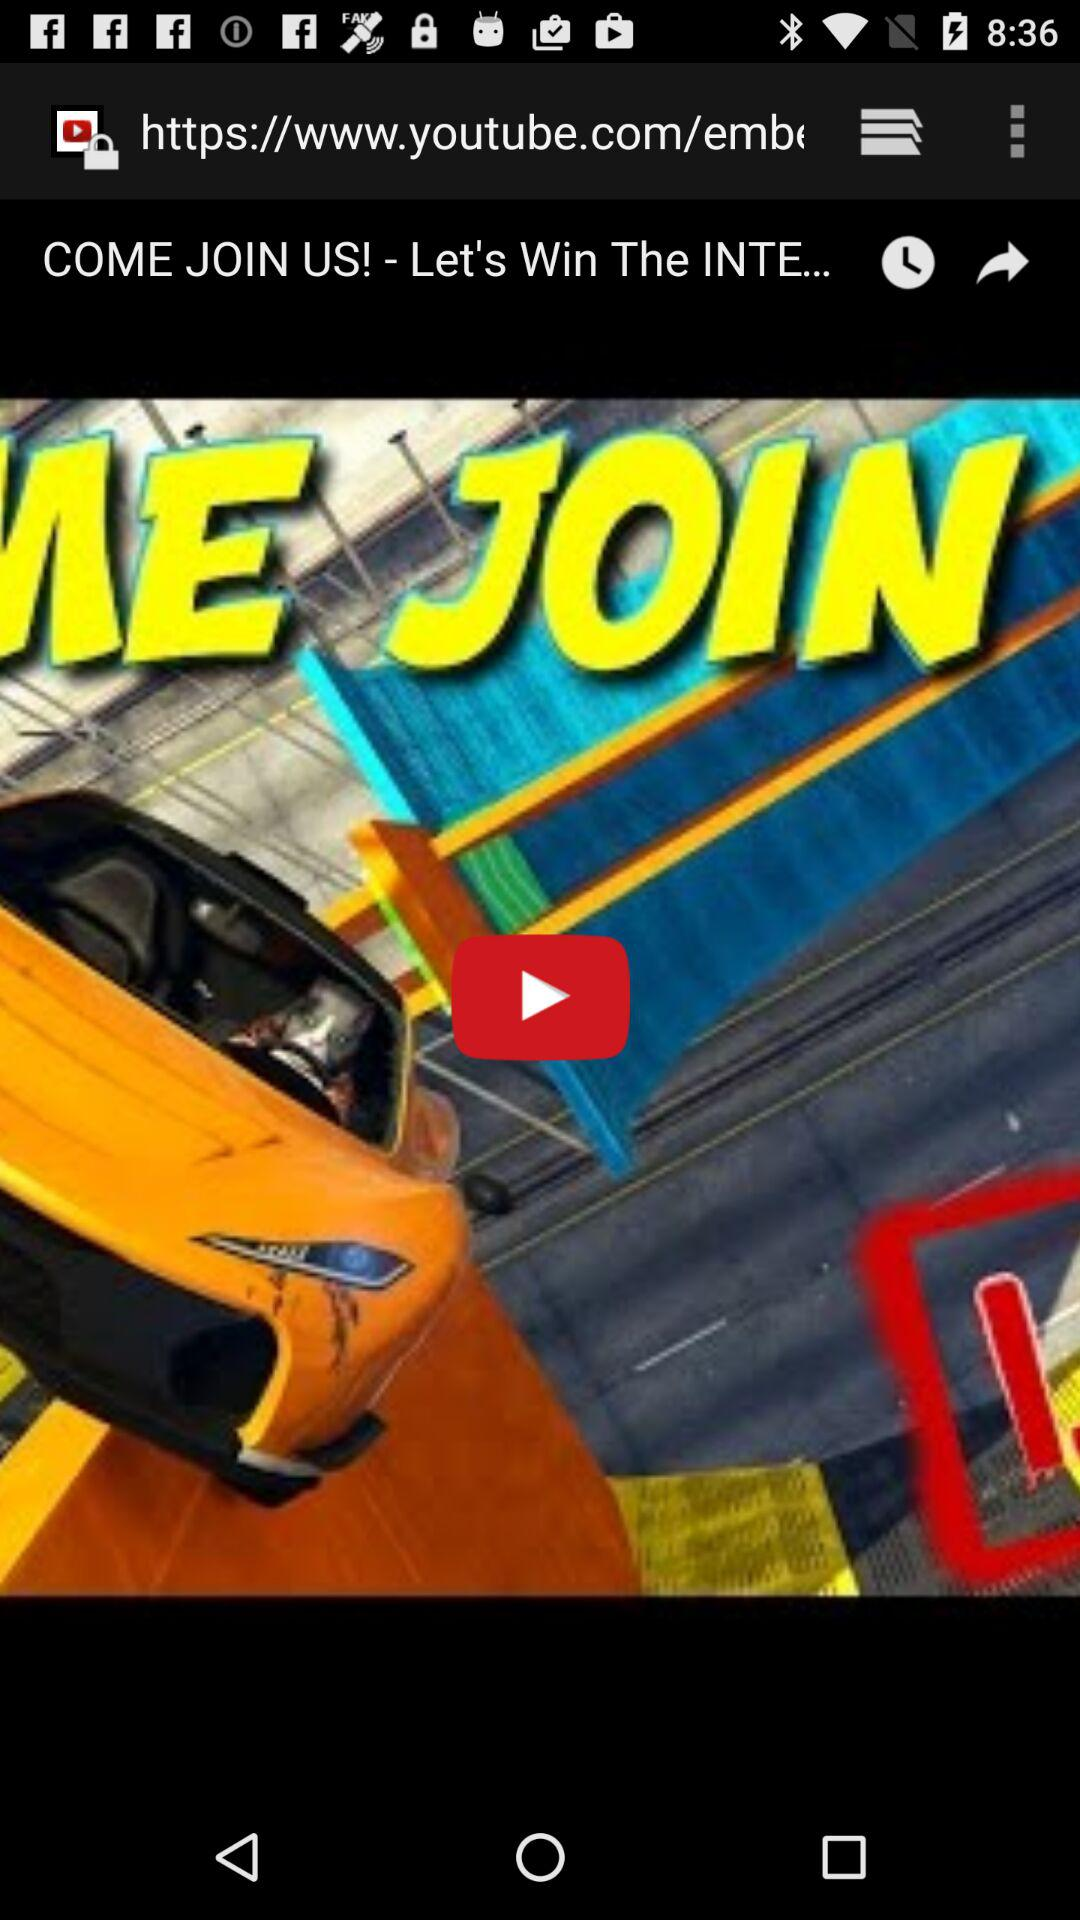What is the title of the current video? The title of the current video is "COME JOIN US! - Let's Win The INTE...". 